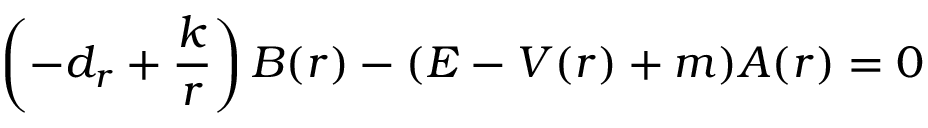Convert formula to latex. <formula><loc_0><loc_0><loc_500><loc_500>\left ( - d _ { r } + \frac { k } { r } \right ) B ( r ) - ( E - V ( r ) + m ) A ( r ) = 0</formula> 